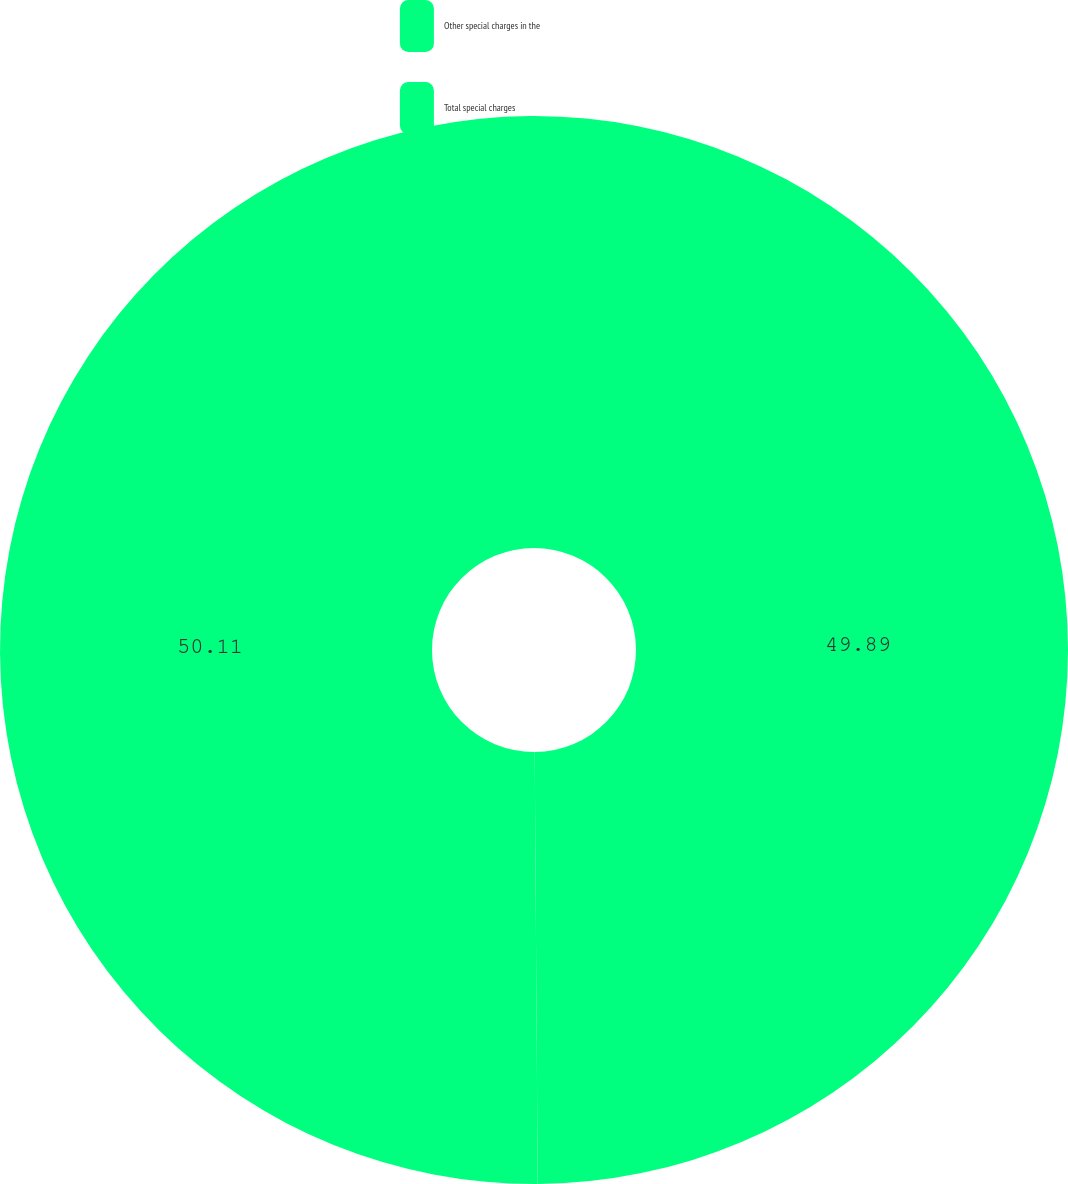Convert chart to OTSL. <chart><loc_0><loc_0><loc_500><loc_500><pie_chart><fcel>Other special charges in the<fcel>Total special charges<nl><fcel>49.89%<fcel>50.11%<nl></chart> 